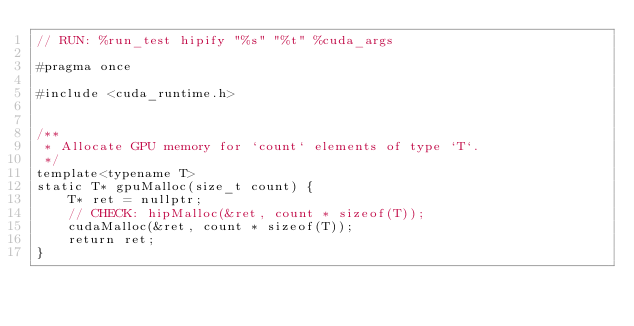<code> <loc_0><loc_0><loc_500><loc_500><_Cuda_>// RUN: %run_test hipify "%s" "%t" %cuda_args

#pragma once

#include <cuda_runtime.h>


/**
 * Allocate GPU memory for `count` elements of type `T`.
 */
template<typename T>
static T* gpuMalloc(size_t count) {
    T* ret = nullptr;
    // CHECK: hipMalloc(&ret, count * sizeof(T));
    cudaMalloc(&ret, count * sizeof(T));
    return ret;
}

</code> 